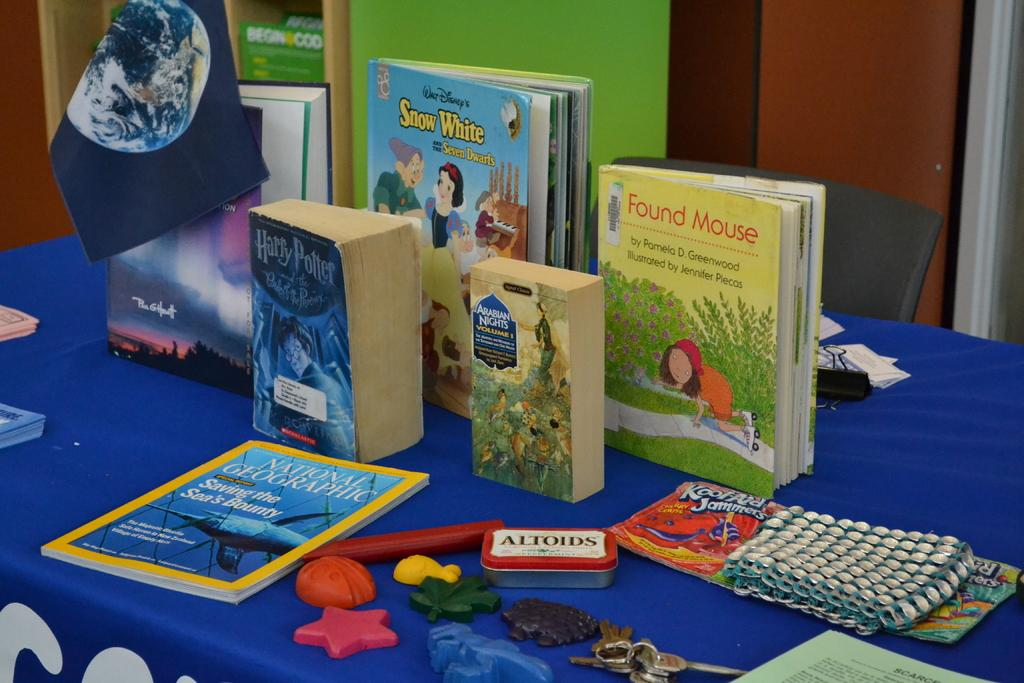<image>
Write a terse but informative summary of the picture. A collection of children's books including Snow White and Harry Potter and a National Geographic magazine about saving the sea's bounty. 